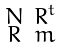<formula> <loc_0><loc_0><loc_500><loc_500>\begin{smallmatrix} N & R ^ { t } \\ R & m \end{smallmatrix}</formula> 